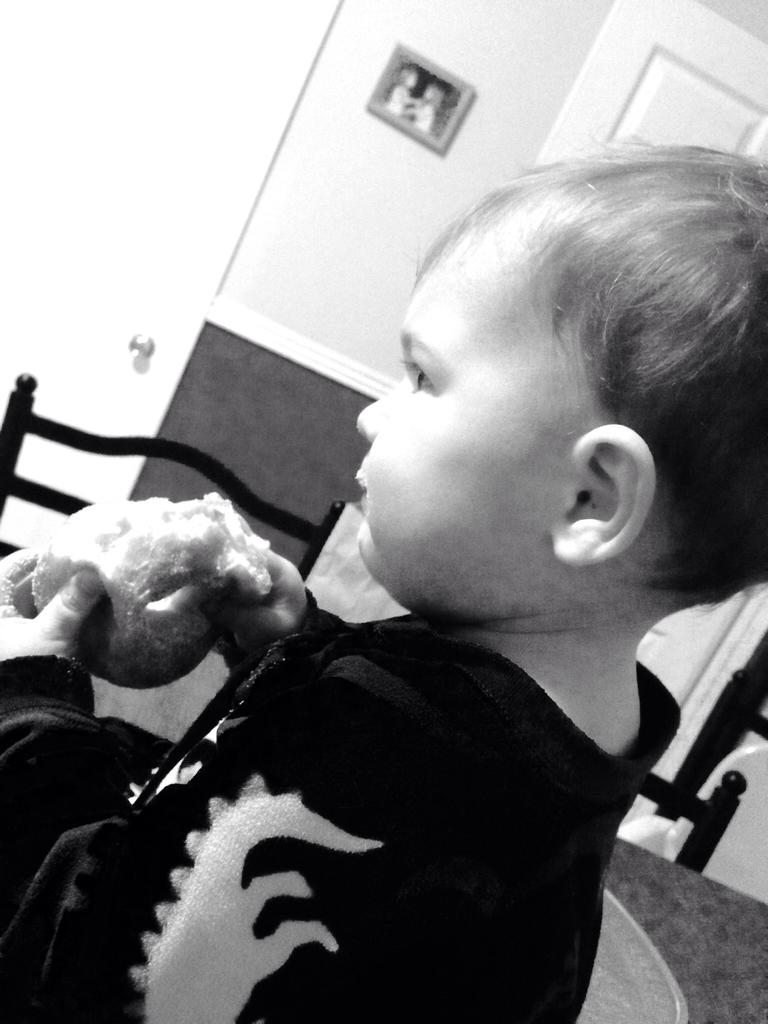What is the kid in the image doing? The kid is sitting in the image. What is the kid holding in the image? The kid is holding a food item. What type of furniture can be seen in the image? There are chairs in the image. What can be seen in the background of the image? There is a wall in the background of the image, and there is a photo on the wall. What architectural feature is visible in the image? There is a door visible in the image. What type of clover is growing on the floor in the image? There is no clover visible on the floor in the image. What type of soap is the kid using to wash their hands in the image? There is no soap or hand-washing activity depicted in the image. 